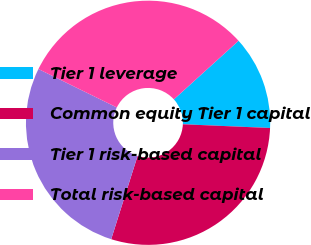<chart> <loc_0><loc_0><loc_500><loc_500><pie_chart><fcel>Tier 1 leverage<fcel>Common equity Tier 1 capital<fcel>Tier 1 risk-based capital<fcel>Total risk-based capital<nl><fcel>12.4%<fcel>29.2%<fcel>27.37%<fcel>31.03%<nl></chart> 